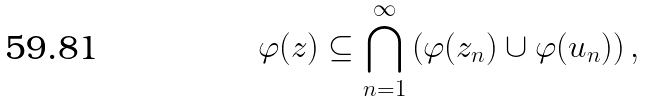<formula> <loc_0><loc_0><loc_500><loc_500>\varphi ( z ) \subseteq \bigcap _ { n = 1 } ^ { \infty } \left ( \varphi ( z _ { n } ) \cup \varphi ( u _ { n } ) \right ) ,</formula> 